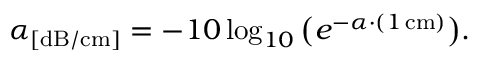<formula> <loc_0><loc_0><loc_500><loc_500>\alpha _ { [ d B / c m ] } = - 1 0 \log _ { 1 0 } \left ( e ^ { - \alpha \cdot ( 1 \, c m ) } \right ) .</formula> 